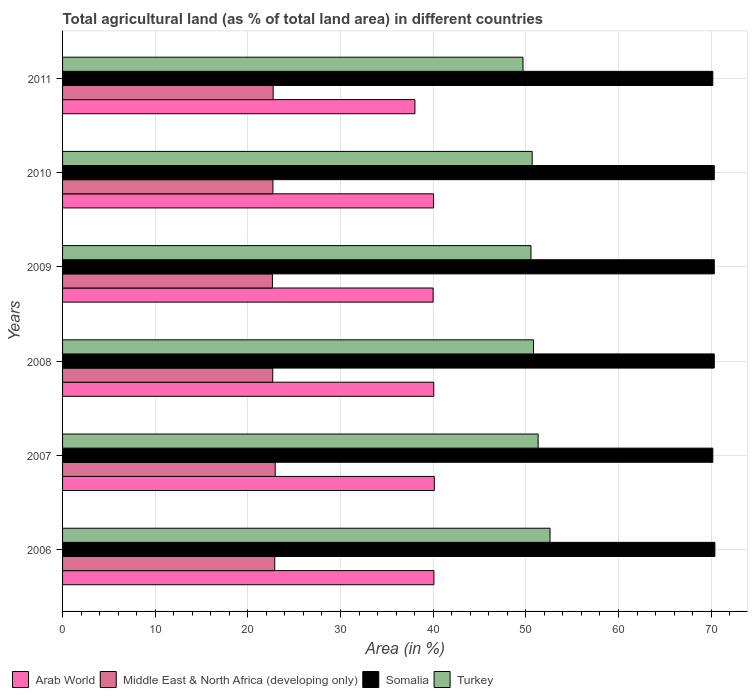How many different coloured bars are there?
Provide a succinct answer. 4. Are the number of bars on each tick of the Y-axis equal?
Ensure brevity in your answer.  Yes. How many bars are there on the 4th tick from the top?
Provide a short and direct response. 4. How many bars are there on the 2nd tick from the bottom?
Provide a short and direct response. 4. What is the label of the 1st group of bars from the top?
Offer a terse response. 2011. In how many cases, is the number of bars for a given year not equal to the number of legend labels?
Give a very brief answer. 0. What is the percentage of agricultural land in Turkey in 2006?
Provide a short and direct response. 52.61. Across all years, what is the maximum percentage of agricultural land in Turkey?
Your answer should be very brief. 52.61. Across all years, what is the minimum percentage of agricultural land in Turkey?
Provide a short and direct response. 49.7. In which year was the percentage of agricultural land in Turkey maximum?
Offer a very short reply. 2006. What is the total percentage of agricultural land in Turkey in the graph?
Provide a succinct answer. 305.72. What is the difference between the percentage of agricultural land in Middle East & North Africa (developing only) in 2009 and that in 2010?
Give a very brief answer. -0.05. What is the difference between the percentage of agricultural land in Somalia in 2009 and the percentage of agricultural land in Arab World in 2008?
Make the answer very short. 30.28. What is the average percentage of agricultural land in Somalia per year?
Offer a terse response. 70.3. In the year 2009, what is the difference between the percentage of agricultural land in Turkey and percentage of agricultural land in Middle East & North Africa (developing only)?
Offer a very short reply. 27.91. What is the ratio of the percentage of agricultural land in Somalia in 2007 to that in 2009?
Provide a short and direct response. 1. What is the difference between the highest and the second highest percentage of agricultural land in Somalia?
Make the answer very short. 0.06. What is the difference between the highest and the lowest percentage of agricultural land in Turkey?
Offer a terse response. 2.92. In how many years, is the percentage of agricultural land in Turkey greater than the average percentage of agricultural land in Turkey taken over all years?
Provide a succinct answer. 2. Is the sum of the percentage of agricultural land in Turkey in 2009 and 2010 greater than the maximum percentage of agricultural land in Arab World across all years?
Give a very brief answer. Yes. What does the 1st bar from the top in 2011 represents?
Ensure brevity in your answer.  Turkey. What does the 3rd bar from the bottom in 2007 represents?
Provide a succinct answer. Somalia. Is it the case that in every year, the sum of the percentage of agricultural land in Middle East & North Africa (developing only) and percentage of agricultural land in Somalia is greater than the percentage of agricultural land in Turkey?
Offer a very short reply. Yes. Are all the bars in the graph horizontal?
Give a very brief answer. Yes. How many years are there in the graph?
Make the answer very short. 6. What is the difference between two consecutive major ticks on the X-axis?
Give a very brief answer. 10. Does the graph contain any zero values?
Make the answer very short. No. Where does the legend appear in the graph?
Provide a succinct answer. Bottom left. How many legend labels are there?
Make the answer very short. 4. How are the legend labels stacked?
Keep it short and to the point. Horizontal. What is the title of the graph?
Offer a terse response. Total agricultural land (as % of total land area) in different countries. Does "High income: nonOECD" appear as one of the legend labels in the graph?
Offer a very short reply. No. What is the label or title of the X-axis?
Offer a terse response. Area (in %). What is the Area (in %) in Arab World in 2006?
Give a very brief answer. 40.08. What is the Area (in %) in Middle East & North Africa (developing only) in 2006?
Provide a short and direct response. 22.9. What is the Area (in %) of Somalia in 2006?
Your response must be concise. 70.41. What is the Area (in %) in Turkey in 2006?
Your response must be concise. 52.61. What is the Area (in %) in Arab World in 2007?
Give a very brief answer. 40.12. What is the Area (in %) in Middle East & North Africa (developing only) in 2007?
Give a very brief answer. 22.95. What is the Area (in %) of Somalia in 2007?
Keep it short and to the point. 70.18. What is the Area (in %) of Turkey in 2007?
Give a very brief answer. 51.33. What is the Area (in %) of Arab World in 2008?
Your answer should be very brief. 40.06. What is the Area (in %) in Middle East & North Africa (developing only) in 2008?
Make the answer very short. 22.68. What is the Area (in %) in Somalia in 2008?
Provide a succinct answer. 70.34. What is the Area (in %) in Turkey in 2008?
Give a very brief answer. 50.83. What is the Area (in %) of Arab World in 2009?
Give a very brief answer. 39.99. What is the Area (in %) of Middle East & North Africa (developing only) in 2009?
Your answer should be very brief. 22.65. What is the Area (in %) of Somalia in 2009?
Your answer should be very brief. 70.34. What is the Area (in %) of Turkey in 2009?
Keep it short and to the point. 50.56. What is the Area (in %) in Arab World in 2010?
Give a very brief answer. 40.04. What is the Area (in %) in Middle East & North Africa (developing only) in 2010?
Your answer should be compact. 22.7. What is the Area (in %) in Somalia in 2010?
Make the answer very short. 70.34. What is the Area (in %) of Turkey in 2010?
Your answer should be very brief. 50.69. What is the Area (in %) in Arab World in 2011?
Keep it short and to the point. 38.03. What is the Area (in %) in Middle East & North Africa (developing only) in 2011?
Give a very brief answer. 22.73. What is the Area (in %) of Somalia in 2011?
Offer a terse response. 70.18. What is the Area (in %) of Turkey in 2011?
Provide a succinct answer. 49.7. Across all years, what is the maximum Area (in %) in Arab World?
Give a very brief answer. 40.12. Across all years, what is the maximum Area (in %) of Middle East & North Africa (developing only)?
Make the answer very short. 22.95. Across all years, what is the maximum Area (in %) in Somalia?
Offer a very short reply. 70.41. Across all years, what is the maximum Area (in %) in Turkey?
Ensure brevity in your answer.  52.61. Across all years, what is the minimum Area (in %) of Arab World?
Your answer should be very brief. 38.03. Across all years, what is the minimum Area (in %) in Middle East & North Africa (developing only)?
Keep it short and to the point. 22.65. Across all years, what is the minimum Area (in %) of Somalia?
Your answer should be compact. 70.18. Across all years, what is the minimum Area (in %) of Turkey?
Your response must be concise. 49.7. What is the total Area (in %) in Arab World in the graph?
Your answer should be compact. 238.33. What is the total Area (in %) of Middle East & North Africa (developing only) in the graph?
Give a very brief answer. 136.62. What is the total Area (in %) of Somalia in the graph?
Ensure brevity in your answer.  421.79. What is the total Area (in %) in Turkey in the graph?
Your answer should be compact. 305.72. What is the difference between the Area (in %) of Arab World in 2006 and that in 2007?
Offer a terse response. -0.05. What is the difference between the Area (in %) of Middle East & North Africa (developing only) in 2006 and that in 2007?
Your answer should be compact. -0.05. What is the difference between the Area (in %) in Somalia in 2006 and that in 2007?
Offer a terse response. 0.22. What is the difference between the Area (in %) in Turkey in 2006 and that in 2007?
Your answer should be compact. 1.28. What is the difference between the Area (in %) of Arab World in 2006 and that in 2008?
Offer a very short reply. 0.01. What is the difference between the Area (in %) in Middle East & North Africa (developing only) in 2006 and that in 2008?
Your answer should be very brief. 0.22. What is the difference between the Area (in %) of Somalia in 2006 and that in 2008?
Your answer should be compact. 0.06. What is the difference between the Area (in %) of Turkey in 2006 and that in 2008?
Make the answer very short. 1.78. What is the difference between the Area (in %) in Arab World in 2006 and that in 2009?
Ensure brevity in your answer.  0.09. What is the difference between the Area (in %) in Middle East & North Africa (developing only) in 2006 and that in 2009?
Make the answer very short. 0.25. What is the difference between the Area (in %) in Somalia in 2006 and that in 2009?
Give a very brief answer. 0.06. What is the difference between the Area (in %) in Turkey in 2006 and that in 2009?
Give a very brief answer. 2.06. What is the difference between the Area (in %) in Arab World in 2006 and that in 2010?
Provide a short and direct response. 0.04. What is the difference between the Area (in %) of Middle East & North Africa (developing only) in 2006 and that in 2010?
Offer a very short reply. 0.2. What is the difference between the Area (in %) of Somalia in 2006 and that in 2010?
Offer a terse response. 0.06. What is the difference between the Area (in %) in Turkey in 2006 and that in 2010?
Offer a terse response. 1.92. What is the difference between the Area (in %) in Arab World in 2006 and that in 2011?
Provide a short and direct response. 2.05. What is the difference between the Area (in %) of Middle East & North Africa (developing only) in 2006 and that in 2011?
Provide a short and direct response. 0.17. What is the difference between the Area (in %) of Somalia in 2006 and that in 2011?
Provide a short and direct response. 0.22. What is the difference between the Area (in %) in Turkey in 2006 and that in 2011?
Provide a short and direct response. 2.92. What is the difference between the Area (in %) of Middle East & North Africa (developing only) in 2007 and that in 2008?
Provide a short and direct response. 0.27. What is the difference between the Area (in %) of Somalia in 2007 and that in 2008?
Your answer should be compact. -0.16. What is the difference between the Area (in %) of Turkey in 2007 and that in 2008?
Provide a short and direct response. 0.5. What is the difference between the Area (in %) of Arab World in 2007 and that in 2009?
Provide a succinct answer. 0.13. What is the difference between the Area (in %) in Middle East & North Africa (developing only) in 2007 and that in 2009?
Ensure brevity in your answer.  0.3. What is the difference between the Area (in %) in Somalia in 2007 and that in 2009?
Make the answer very short. -0.16. What is the difference between the Area (in %) in Turkey in 2007 and that in 2009?
Give a very brief answer. 0.77. What is the difference between the Area (in %) in Arab World in 2007 and that in 2010?
Offer a very short reply. 0.08. What is the difference between the Area (in %) in Middle East & North Africa (developing only) in 2007 and that in 2010?
Provide a succinct answer. 0.25. What is the difference between the Area (in %) of Somalia in 2007 and that in 2010?
Give a very brief answer. -0.16. What is the difference between the Area (in %) in Turkey in 2007 and that in 2010?
Your response must be concise. 0.64. What is the difference between the Area (in %) in Arab World in 2007 and that in 2011?
Offer a terse response. 2.09. What is the difference between the Area (in %) of Middle East & North Africa (developing only) in 2007 and that in 2011?
Provide a succinct answer. 0.22. What is the difference between the Area (in %) in Somalia in 2007 and that in 2011?
Provide a short and direct response. 0. What is the difference between the Area (in %) of Turkey in 2007 and that in 2011?
Your response must be concise. 1.63. What is the difference between the Area (in %) in Arab World in 2008 and that in 2009?
Keep it short and to the point. 0.07. What is the difference between the Area (in %) in Middle East & North Africa (developing only) in 2008 and that in 2009?
Your response must be concise. 0.03. What is the difference between the Area (in %) of Turkey in 2008 and that in 2009?
Your answer should be very brief. 0.27. What is the difference between the Area (in %) of Arab World in 2008 and that in 2010?
Your answer should be very brief. 0.02. What is the difference between the Area (in %) of Middle East & North Africa (developing only) in 2008 and that in 2010?
Make the answer very short. -0.02. What is the difference between the Area (in %) of Somalia in 2008 and that in 2010?
Make the answer very short. 0. What is the difference between the Area (in %) of Turkey in 2008 and that in 2010?
Offer a terse response. 0.14. What is the difference between the Area (in %) in Arab World in 2008 and that in 2011?
Your answer should be very brief. 2.03. What is the difference between the Area (in %) in Middle East & North Africa (developing only) in 2008 and that in 2011?
Ensure brevity in your answer.  -0.04. What is the difference between the Area (in %) of Somalia in 2008 and that in 2011?
Offer a terse response. 0.16. What is the difference between the Area (in %) in Turkey in 2008 and that in 2011?
Keep it short and to the point. 1.14. What is the difference between the Area (in %) of Arab World in 2009 and that in 2010?
Give a very brief answer. -0.05. What is the difference between the Area (in %) in Middle East & North Africa (developing only) in 2009 and that in 2010?
Give a very brief answer. -0.05. What is the difference between the Area (in %) of Turkey in 2009 and that in 2010?
Give a very brief answer. -0.13. What is the difference between the Area (in %) of Arab World in 2009 and that in 2011?
Your answer should be very brief. 1.96. What is the difference between the Area (in %) of Middle East & North Africa (developing only) in 2009 and that in 2011?
Make the answer very short. -0.08. What is the difference between the Area (in %) in Somalia in 2009 and that in 2011?
Give a very brief answer. 0.16. What is the difference between the Area (in %) in Turkey in 2009 and that in 2011?
Your answer should be compact. 0.86. What is the difference between the Area (in %) in Arab World in 2010 and that in 2011?
Offer a terse response. 2.01. What is the difference between the Area (in %) in Middle East & North Africa (developing only) in 2010 and that in 2011?
Your answer should be compact. -0.03. What is the difference between the Area (in %) in Somalia in 2010 and that in 2011?
Offer a terse response. 0.16. What is the difference between the Area (in %) in Turkey in 2010 and that in 2011?
Provide a succinct answer. 0.99. What is the difference between the Area (in %) in Arab World in 2006 and the Area (in %) in Middle East & North Africa (developing only) in 2007?
Offer a terse response. 17.13. What is the difference between the Area (in %) of Arab World in 2006 and the Area (in %) of Somalia in 2007?
Provide a short and direct response. -30.1. What is the difference between the Area (in %) of Arab World in 2006 and the Area (in %) of Turkey in 2007?
Offer a very short reply. -11.25. What is the difference between the Area (in %) of Middle East & North Africa (developing only) in 2006 and the Area (in %) of Somalia in 2007?
Keep it short and to the point. -47.28. What is the difference between the Area (in %) of Middle East & North Africa (developing only) in 2006 and the Area (in %) of Turkey in 2007?
Your answer should be very brief. -28.43. What is the difference between the Area (in %) in Somalia in 2006 and the Area (in %) in Turkey in 2007?
Give a very brief answer. 19.08. What is the difference between the Area (in %) in Arab World in 2006 and the Area (in %) in Middle East & North Africa (developing only) in 2008?
Give a very brief answer. 17.39. What is the difference between the Area (in %) in Arab World in 2006 and the Area (in %) in Somalia in 2008?
Your answer should be compact. -30.26. What is the difference between the Area (in %) in Arab World in 2006 and the Area (in %) in Turkey in 2008?
Make the answer very short. -10.75. What is the difference between the Area (in %) of Middle East & North Africa (developing only) in 2006 and the Area (in %) of Somalia in 2008?
Provide a short and direct response. -47.44. What is the difference between the Area (in %) in Middle East & North Africa (developing only) in 2006 and the Area (in %) in Turkey in 2008?
Offer a terse response. -27.93. What is the difference between the Area (in %) in Somalia in 2006 and the Area (in %) in Turkey in 2008?
Provide a short and direct response. 19.57. What is the difference between the Area (in %) in Arab World in 2006 and the Area (in %) in Middle East & North Africa (developing only) in 2009?
Your response must be concise. 17.43. What is the difference between the Area (in %) of Arab World in 2006 and the Area (in %) of Somalia in 2009?
Provide a short and direct response. -30.26. What is the difference between the Area (in %) of Arab World in 2006 and the Area (in %) of Turkey in 2009?
Keep it short and to the point. -10.48. What is the difference between the Area (in %) of Middle East & North Africa (developing only) in 2006 and the Area (in %) of Somalia in 2009?
Provide a succinct answer. -47.44. What is the difference between the Area (in %) of Middle East & North Africa (developing only) in 2006 and the Area (in %) of Turkey in 2009?
Offer a terse response. -27.66. What is the difference between the Area (in %) in Somalia in 2006 and the Area (in %) in Turkey in 2009?
Ensure brevity in your answer.  19.85. What is the difference between the Area (in %) of Arab World in 2006 and the Area (in %) of Middle East & North Africa (developing only) in 2010?
Offer a terse response. 17.37. What is the difference between the Area (in %) in Arab World in 2006 and the Area (in %) in Somalia in 2010?
Your answer should be compact. -30.26. What is the difference between the Area (in %) in Arab World in 2006 and the Area (in %) in Turkey in 2010?
Offer a terse response. -10.61. What is the difference between the Area (in %) in Middle East & North Africa (developing only) in 2006 and the Area (in %) in Somalia in 2010?
Offer a very short reply. -47.44. What is the difference between the Area (in %) of Middle East & North Africa (developing only) in 2006 and the Area (in %) of Turkey in 2010?
Provide a short and direct response. -27.79. What is the difference between the Area (in %) in Somalia in 2006 and the Area (in %) in Turkey in 2010?
Provide a succinct answer. 19.72. What is the difference between the Area (in %) in Arab World in 2006 and the Area (in %) in Middle East & North Africa (developing only) in 2011?
Offer a very short reply. 17.35. What is the difference between the Area (in %) in Arab World in 2006 and the Area (in %) in Somalia in 2011?
Provide a short and direct response. -30.1. What is the difference between the Area (in %) of Arab World in 2006 and the Area (in %) of Turkey in 2011?
Give a very brief answer. -9.62. What is the difference between the Area (in %) in Middle East & North Africa (developing only) in 2006 and the Area (in %) in Somalia in 2011?
Give a very brief answer. -47.28. What is the difference between the Area (in %) of Middle East & North Africa (developing only) in 2006 and the Area (in %) of Turkey in 2011?
Provide a short and direct response. -26.79. What is the difference between the Area (in %) in Somalia in 2006 and the Area (in %) in Turkey in 2011?
Keep it short and to the point. 20.71. What is the difference between the Area (in %) of Arab World in 2007 and the Area (in %) of Middle East & North Africa (developing only) in 2008?
Offer a very short reply. 17.44. What is the difference between the Area (in %) in Arab World in 2007 and the Area (in %) in Somalia in 2008?
Ensure brevity in your answer.  -30.22. What is the difference between the Area (in %) in Arab World in 2007 and the Area (in %) in Turkey in 2008?
Provide a short and direct response. -10.71. What is the difference between the Area (in %) in Middle East & North Africa (developing only) in 2007 and the Area (in %) in Somalia in 2008?
Offer a terse response. -47.39. What is the difference between the Area (in %) of Middle East & North Africa (developing only) in 2007 and the Area (in %) of Turkey in 2008?
Offer a terse response. -27.88. What is the difference between the Area (in %) in Somalia in 2007 and the Area (in %) in Turkey in 2008?
Your response must be concise. 19.35. What is the difference between the Area (in %) of Arab World in 2007 and the Area (in %) of Middle East & North Africa (developing only) in 2009?
Make the answer very short. 17.47. What is the difference between the Area (in %) of Arab World in 2007 and the Area (in %) of Somalia in 2009?
Ensure brevity in your answer.  -30.22. What is the difference between the Area (in %) of Arab World in 2007 and the Area (in %) of Turkey in 2009?
Ensure brevity in your answer.  -10.43. What is the difference between the Area (in %) in Middle East & North Africa (developing only) in 2007 and the Area (in %) in Somalia in 2009?
Offer a terse response. -47.39. What is the difference between the Area (in %) in Middle East & North Africa (developing only) in 2007 and the Area (in %) in Turkey in 2009?
Offer a very short reply. -27.61. What is the difference between the Area (in %) of Somalia in 2007 and the Area (in %) of Turkey in 2009?
Provide a succinct answer. 19.62. What is the difference between the Area (in %) in Arab World in 2007 and the Area (in %) in Middle East & North Africa (developing only) in 2010?
Keep it short and to the point. 17.42. What is the difference between the Area (in %) in Arab World in 2007 and the Area (in %) in Somalia in 2010?
Give a very brief answer. -30.22. What is the difference between the Area (in %) in Arab World in 2007 and the Area (in %) in Turkey in 2010?
Ensure brevity in your answer.  -10.57. What is the difference between the Area (in %) in Middle East & North Africa (developing only) in 2007 and the Area (in %) in Somalia in 2010?
Keep it short and to the point. -47.39. What is the difference between the Area (in %) in Middle East & North Africa (developing only) in 2007 and the Area (in %) in Turkey in 2010?
Make the answer very short. -27.74. What is the difference between the Area (in %) in Somalia in 2007 and the Area (in %) in Turkey in 2010?
Provide a short and direct response. 19.49. What is the difference between the Area (in %) of Arab World in 2007 and the Area (in %) of Middle East & North Africa (developing only) in 2011?
Keep it short and to the point. 17.39. What is the difference between the Area (in %) in Arab World in 2007 and the Area (in %) in Somalia in 2011?
Provide a short and direct response. -30.06. What is the difference between the Area (in %) in Arab World in 2007 and the Area (in %) in Turkey in 2011?
Your answer should be very brief. -9.57. What is the difference between the Area (in %) in Middle East & North Africa (developing only) in 2007 and the Area (in %) in Somalia in 2011?
Give a very brief answer. -47.23. What is the difference between the Area (in %) in Middle East & North Africa (developing only) in 2007 and the Area (in %) in Turkey in 2011?
Provide a succinct answer. -26.75. What is the difference between the Area (in %) of Somalia in 2007 and the Area (in %) of Turkey in 2011?
Your response must be concise. 20.49. What is the difference between the Area (in %) of Arab World in 2008 and the Area (in %) of Middle East & North Africa (developing only) in 2009?
Ensure brevity in your answer.  17.41. What is the difference between the Area (in %) in Arab World in 2008 and the Area (in %) in Somalia in 2009?
Your answer should be compact. -30.28. What is the difference between the Area (in %) of Arab World in 2008 and the Area (in %) of Turkey in 2009?
Keep it short and to the point. -10.49. What is the difference between the Area (in %) of Middle East & North Africa (developing only) in 2008 and the Area (in %) of Somalia in 2009?
Provide a succinct answer. -47.66. What is the difference between the Area (in %) in Middle East & North Africa (developing only) in 2008 and the Area (in %) in Turkey in 2009?
Offer a very short reply. -27.87. What is the difference between the Area (in %) of Somalia in 2008 and the Area (in %) of Turkey in 2009?
Provide a succinct answer. 19.78. What is the difference between the Area (in %) of Arab World in 2008 and the Area (in %) of Middle East & North Africa (developing only) in 2010?
Keep it short and to the point. 17.36. What is the difference between the Area (in %) of Arab World in 2008 and the Area (in %) of Somalia in 2010?
Keep it short and to the point. -30.28. What is the difference between the Area (in %) in Arab World in 2008 and the Area (in %) in Turkey in 2010?
Offer a terse response. -10.63. What is the difference between the Area (in %) in Middle East & North Africa (developing only) in 2008 and the Area (in %) in Somalia in 2010?
Keep it short and to the point. -47.66. What is the difference between the Area (in %) of Middle East & North Africa (developing only) in 2008 and the Area (in %) of Turkey in 2010?
Offer a terse response. -28. What is the difference between the Area (in %) in Somalia in 2008 and the Area (in %) in Turkey in 2010?
Provide a succinct answer. 19.65. What is the difference between the Area (in %) in Arab World in 2008 and the Area (in %) in Middle East & North Africa (developing only) in 2011?
Give a very brief answer. 17.33. What is the difference between the Area (in %) of Arab World in 2008 and the Area (in %) of Somalia in 2011?
Give a very brief answer. -30.12. What is the difference between the Area (in %) in Arab World in 2008 and the Area (in %) in Turkey in 2011?
Your answer should be compact. -9.63. What is the difference between the Area (in %) of Middle East & North Africa (developing only) in 2008 and the Area (in %) of Somalia in 2011?
Ensure brevity in your answer.  -47.5. What is the difference between the Area (in %) in Middle East & North Africa (developing only) in 2008 and the Area (in %) in Turkey in 2011?
Offer a very short reply. -27.01. What is the difference between the Area (in %) of Somalia in 2008 and the Area (in %) of Turkey in 2011?
Offer a very short reply. 20.65. What is the difference between the Area (in %) in Arab World in 2009 and the Area (in %) in Middle East & North Africa (developing only) in 2010?
Offer a terse response. 17.29. What is the difference between the Area (in %) in Arab World in 2009 and the Area (in %) in Somalia in 2010?
Provide a short and direct response. -30.35. What is the difference between the Area (in %) in Arab World in 2009 and the Area (in %) in Turkey in 2010?
Provide a short and direct response. -10.7. What is the difference between the Area (in %) of Middle East & North Africa (developing only) in 2009 and the Area (in %) of Somalia in 2010?
Your answer should be very brief. -47.69. What is the difference between the Area (in %) of Middle East & North Africa (developing only) in 2009 and the Area (in %) of Turkey in 2010?
Your response must be concise. -28.04. What is the difference between the Area (in %) in Somalia in 2009 and the Area (in %) in Turkey in 2010?
Provide a short and direct response. 19.65. What is the difference between the Area (in %) in Arab World in 2009 and the Area (in %) in Middle East & North Africa (developing only) in 2011?
Provide a succinct answer. 17.26. What is the difference between the Area (in %) of Arab World in 2009 and the Area (in %) of Somalia in 2011?
Give a very brief answer. -30.19. What is the difference between the Area (in %) of Arab World in 2009 and the Area (in %) of Turkey in 2011?
Your answer should be very brief. -9.7. What is the difference between the Area (in %) in Middle East & North Africa (developing only) in 2009 and the Area (in %) in Somalia in 2011?
Your answer should be very brief. -47.53. What is the difference between the Area (in %) in Middle East & North Africa (developing only) in 2009 and the Area (in %) in Turkey in 2011?
Your answer should be compact. -27.05. What is the difference between the Area (in %) of Somalia in 2009 and the Area (in %) of Turkey in 2011?
Give a very brief answer. 20.65. What is the difference between the Area (in %) of Arab World in 2010 and the Area (in %) of Middle East & North Africa (developing only) in 2011?
Make the answer very short. 17.31. What is the difference between the Area (in %) in Arab World in 2010 and the Area (in %) in Somalia in 2011?
Your response must be concise. -30.14. What is the difference between the Area (in %) of Arab World in 2010 and the Area (in %) of Turkey in 2011?
Your answer should be very brief. -9.65. What is the difference between the Area (in %) of Middle East & North Africa (developing only) in 2010 and the Area (in %) of Somalia in 2011?
Make the answer very short. -47.48. What is the difference between the Area (in %) of Middle East & North Africa (developing only) in 2010 and the Area (in %) of Turkey in 2011?
Ensure brevity in your answer.  -26.99. What is the difference between the Area (in %) of Somalia in 2010 and the Area (in %) of Turkey in 2011?
Provide a succinct answer. 20.65. What is the average Area (in %) of Arab World per year?
Keep it short and to the point. 39.72. What is the average Area (in %) in Middle East & North Africa (developing only) per year?
Your answer should be very brief. 22.77. What is the average Area (in %) in Somalia per year?
Make the answer very short. 70.3. What is the average Area (in %) in Turkey per year?
Your answer should be compact. 50.95. In the year 2006, what is the difference between the Area (in %) in Arab World and Area (in %) in Middle East & North Africa (developing only)?
Your response must be concise. 17.18. In the year 2006, what is the difference between the Area (in %) in Arab World and Area (in %) in Somalia?
Keep it short and to the point. -30.33. In the year 2006, what is the difference between the Area (in %) in Arab World and Area (in %) in Turkey?
Your answer should be compact. -12.54. In the year 2006, what is the difference between the Area (in %) in Middle East & North Africa (developing only) and Area (in %) in Somalia?
Ensure brevity in your answer.  -47.5. In the year 2006, what is the difference between the Area (in %) in Middle East & North Africa (developing only) and Area (in %) in Turkey?
Offer a very short reply. -29.71. In the year 2006, what is the difference between the Area (in %) of Somalia and Area (in %) of Turkey?
Give a very brief answer. 17.79. In the year 2007, what is the difference between the Area (in %) of Arab World and Area (in %) of Middle East & North Africa (developing only)?
Keep it short and to the point. 17.17. In the year 2007, what is the difference between the Area (in %) of Arab World and Area (in %) of Somalia?
Your answer should be very brief. -30.06. In the year 2007, what is the difference between the Area (in %) of Arab World and Area (in %) of Turkey?
Provide a short and direct response. -11.21. In the year 2007, what is the difference between the Area (in %) in Middle East & North Africa (developing only) and Area (in %) in Somalia?
Your answer should be very brief. -47.23. In the year 2007, what is the difference between the Area (in %) of Middle East & North Africa (developing only) and Area (in %) of Turkey?
Keep it short and to the point. -28.38. In the year 2007, what is the difference between the Area (in %) in Somalia and Area (in %) in Turkey?
Your response must be concise. 18.85. In the year 2008, what is the difference between the Area (in %) of Arab World and Area (in %) of Middle East & North Africa (developing only)?
Provide a short and direct response. 17.38. In the year 2008, what is the difference between the Area (in %) of Arab World and Area (in %) of Somalia?
Offer a very short reply. -30.28. In the year 2008, what is the difference between the Area (in %) in Arab World and Area (in %) in Turkey?
Ensure brevity in your answer.  -10.77. In the year 2008, what is the difference between the Area (in %) of Middle East & North Africa (developing only) and Area (in %) of Somalia?
Keep it short and to the point. -47.66. In the year 2008, what is the difference between the Area (in %) of Middle East & North Africa (developing only) and Area (in %) of Turkey?
Provide a short and direct response. -28.15. In the year 2008, what is the difference between the Area (in %) of Somalia and Area (in %) of Turkey?
Offer a very short reply. 19.51. In the year 2009, what is the difference between the Area (in %) in Arab World and Area (in %) in Middle East & North Africa (developing only)?
Keep it short and to the point. 17.34. In the year 2009, what is the difference between the Area (in %) in Arab World and Area (in %) in Somalia?
Keep it short and to the point. -30.35. In the year 2009, what is the difference between the Area (in %) in Arab World and Area (in %) in Turkey?
Make the answer very short. -10.57. In the year 2009, what is the difference between the Area (in %) of Middle East & North Africa (developing only) and Area (in %) of Somalia?
Offer a terse response. -47.69. In the year 2009, what is the difference between the Area (in %) in Middle East & North Africa (developing only) and Area (in %) in Turkey?
Offer a very short reply. -27.91. In the year 2009, what is the difference between the Area (in %) in Somalia and Area (in %) in Turkey?
Your response must be concise. 19.78. In the year 2010, what is the difference between the Area (in %) in Arab World and Area (in %) in Middle East & North Africa (developing only)?
Offer a very short reply. 17.34. In the year 2010, what is the difference between the Area (in %) of Arab World and Area (in %) of Somalia?
Offer a very short reply. -30.3. In the year 2010, what is the difference between the Area (in %) of Arab World and Area (in %) of Turkey?
Ensure brevity in your answer.  -10.65. In the year 2010, what is the difference between the Area (in %) in Middle East & North Africa (developing only) and Area (in %) in Somalia?
Ensure brevity in your answer.  -47.64. In the year 2010, what is the difference between the Area (in %) of Middle East & North Africa (developing only) and Area (in %) of Turkey?
Offer a terse response. -27.98. In the year 2010, what is the difference between the Area (in %) in Somalia and Area (in %) in Turkey?
Offer a very short reply. 19.65. In the year 2011, what is the difference between the Area (in %) in Arab World and Area (in %) in Middle East & North Africa (developing only)?
Provide a succinct answer. 15.3. In the year 2011, what is the difference between the Area (in %) in Arab World and Area (in %) in Somalia?
Provide a succinct answer. -32.15. In the year 2011, what is the difference between the Area (in %) in Arab World and Area (in %) in Turkey?
Offer a very short reply. -11.66. In the year 2011, what is the difference between the Area (in %) in Middle East & North Africa (developing only) and Area (in %) in Somalia?
Give a very brief answer. -47.45. In the year 2011, what is the difference between the Area (in %) of Middle East & North Africa (developing only) and Area (in %) of Turkey?
Ensure brevity in your answer.  -26.97. In the year 2011, what is the difference between the Area (in %) of Somalia and Area (in %) of Turkey?
Your answer should be compact. 20.49. What is the ratio of the Area (in %) of Arab World in 2006 to that in 2007?
Offer a very short reply. 1. What is the ratio of the Area (in %) of Middle East & North Africa (developing only) in 2006 to that in 2007?
Your answer should be compact. 1. What is the ratio of the Area (in %) in Middle East & North Africa (developing only) in 2006 to that in 2008?
Offer a terse response. 1.01. What is the ratio of the Area (in %) of Turkey in 2006 to that in 2008?
Provide a short and direct response. 1.03. What is the ratio of the Area (in %) in Arab World in 2006 to that in 2009?
Offer a very short reply. 1. What is the ratio of the Area (in %) of Middle East & North Africa (developing only) in 2006 to that in 2009?
Provide a short and direct response. 1.01. What is the ratio of the Area (in %) of Turkey in 2006 to that in 2009?
Provide a succinct answer. 1.04. What is the ratio of the Area (in %) of Arab World in 2006 to that in 2010?
Provide a succinct answer. 1. What is the ratio of the Area (in %) in Middle East & North Africa (developing only) in 2006 to that in 2010?
Your answer should be compact. 1.01. What is the ratio of the Area (in %) in Somalia in 2006 to that in 2010?
Make the answer very short. 1. What is the ratio of the Area (in %) of Turkey in 2006 to that in 2010?
Provide a short and direct response. 1.04. What is the ratio of the Area (in %) of Arab World in 2006 to that in 2011?
Your answer should be very brief. 1.05. What is the ratio of the Area (in %) in Middle East & North Africa (developing only) in 2006 to that in 2011?
Make the answer very short. 1.01. What is the ratio of the Area (in %) of Turkey in 2006 to that in 2011?
Provide a short and direct response. 1.06. What is the ratio of the Area (in %) in Middle East & North Africa (developing only) in 2007 to that in 2008?
Your answer should be compact. 1.01. What is the ratio of the Area (in %) of Somalia in 2007 to that in 2008?
Give a very brief answer. 1. What is the ratio of the Area (in %) in Turkey in 2007 to that in 2008?
Give a very brief answer. 1.01. What is the ratio of the Area (in %) of Middle East & North Africa (developing only) in 2007 to that in 2009?
Make the answer very short. 1.01. What is the ratio of the Area (in %) of Somalia in 2007 to that in 2009?
Make the answer very short. 1. What is the ratio of the Area (in %) in Turkey in 2007 to that in 2009?
Offer a very short reply. 1.02. What is the ratio of the Area (in %) of Middle East & North Africa (developing only) in 2007 to that in 2010?
Offer a terse response. 1.01. What is the ratio of the Area (in %) of Somalia in 2007 to that in 2010?
Offer a very short reply. 1. What is the ratio of the Area (in %) in Turkey in 2007 to that in 2010?
Your response must be concise. 1.01. What is the ratio of the Area (in %) of Arab World in 2007 to that in 2011?
Give a very brief answer. 1.05. What is the ratio of the Area (in %) of Middle East & North Africa (developing only) in 2007 to that in 2011?
Make the answer very short. 1.01. What is the ratio of the Area (in %) in Turkey in 2007 to that in 2011?
Provide a succinct answer. 1.03. What is the ratio of the Area (in %) in Arab World in 2008 to that in 2009?
Offer a very short reply. 1. What is the ratio of the Area (in %) in Turkey in 2008 to that in 2009?
Your answer should be compact. 1.01. What is the ratio of the Area (in %) in Arab World in 2008 to that in 2010?
Provide a succinct answer. 1. What is the ratio of the Area (in %) of Somalia in 2008 to that in 2010?
Offer a terse response. 1. What is the ratio of the Area (in %) of Arab World in 2008 to that in 2011?
Make the answer very short. 1.05. What is the ratio of the Area (in %) in Middle East & North Africa (developing only) in 2008 to that in 2011?
Offer a terse response. 1. What is the ratio of the Area (in %) in Turkey in 2008 to that in 2011?
Provide a succinct answer. 1.02. What is the ratio of the Area (in %) in Middle East & North Africa (developing only) in 2009 to that in 2010?
Offer a terse response. 1. What is the ratio of the Area (in %) in Somalia in 2009 to that in 2010?
Ensure brevity in your answer.  1. What is the ratio of the Area (in %) in Turkey in 2009 to that in 2010?
Give a very brief answer. 1. What is the ratio of the Area (in %) of Arab World in 2009 to that in 2011?
Make the answer very short. 1.05. What is the ratio of the Area (in %) in Middle East & North Africa (developing only) in 2009 to that in 2011?
Your response must be concise. 1. What is the ratio of the Area (in %) of Somalia in 2009 to that in 2011?
Provide a short and direct response. 1. What is the ratio of the Area (in %) in Turkey in 2009 to that in 2011?
Your answer should be compact. 1.02. What is the ratio of the Area (in %) in Arab World in 2010 to that in 2011?
Provide a succinct answer. 1.05. What is the ratio of the Area (in %) of Middle East & North Africa (developing only) in 2010 to that in 2011?
Make the answer very short. 1. What is the difference between the highest and the second highest Area (in %) in Arab World?
Your response must be concise. 0.05. What is the difference between the highest and the second highest Area (in %) of Middle East & North Africa (developing only)?
Provide a succinct answer. 0.05. What is the difference between the highest and the second highest Area (in %) of Somalia?
Your response must be concise. 0.06. What is the difference between the highest and the second highest Area (in %) of Turkey?
Your answer should be very brief. 1.28. What is the difference between the highest and the lowest Area (in %) in Arab World?
Keep it short and to the point. 2.09. What is the difference between the highest and the lowest Area (in %) in Middle East & North Africa (developing only)?
Your answer should be compact. 0.3. What is the difference between the highest and the lowest Area (in %) of Somalia?
Keep it short and to the point. 0.22. What is the difference between the highest and the lowest Area (in %) of Turkey?
Your response must be concise. 2.92. 